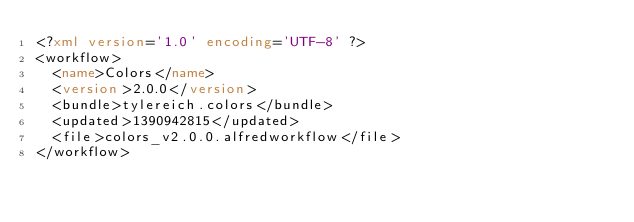Convert code to text. <code><loc_0><loc_0><loc_500><loc_500><_XML_><?xml version='1.0' encoding='UTF-8' ?>
<workflow>
  <name>Colors</name>
  <version>2.0.0</version>
  <bundle>tylereich.colors</bundle>
  <updated>1390942815</updated>
  <file>colors_v2.0.0.alfredworkflow</file>
</workflow>
</code> 